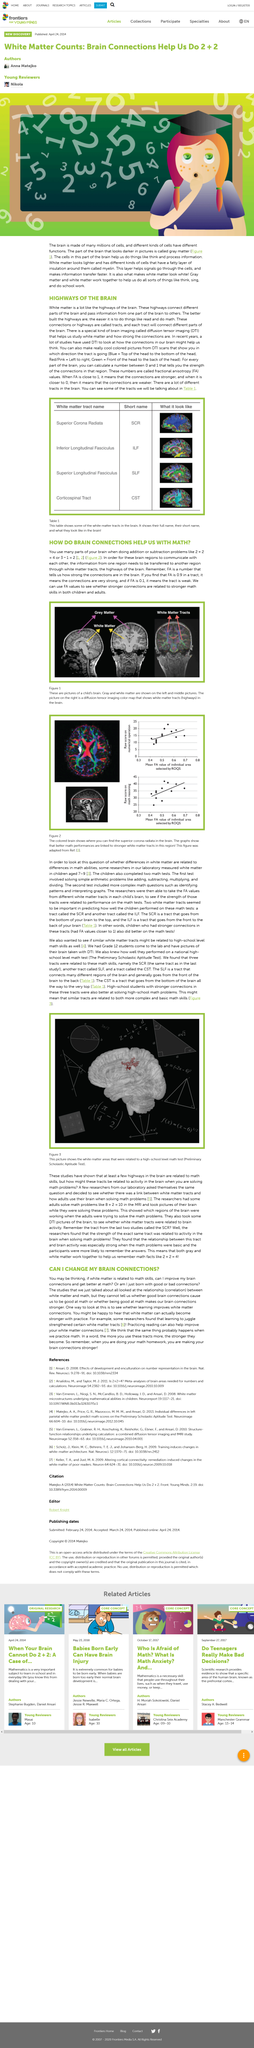Specify some key components in this picture. The darker parts of the brain, which are known as gray matter, are commonly depicted in images. Gray matter is a type of brain tissue that is characterized by its relatively low density and the presence of neuronal cell bodies, neuropil, and glial cells. Gray matter plays a crucial role in the function of the brain, and it is important for the formation and processing of thoughts, emotions, and sensory information. Yes, our brain connections play a crucial role in our ability to perform mathematical tasks. The cells in our gray matter play a crucial role in our ability to think and process information. The result of the calculation 2+2 is 4. The result of 3-1 is 2, as demonstrated by the numerical expression 3-1=2. 